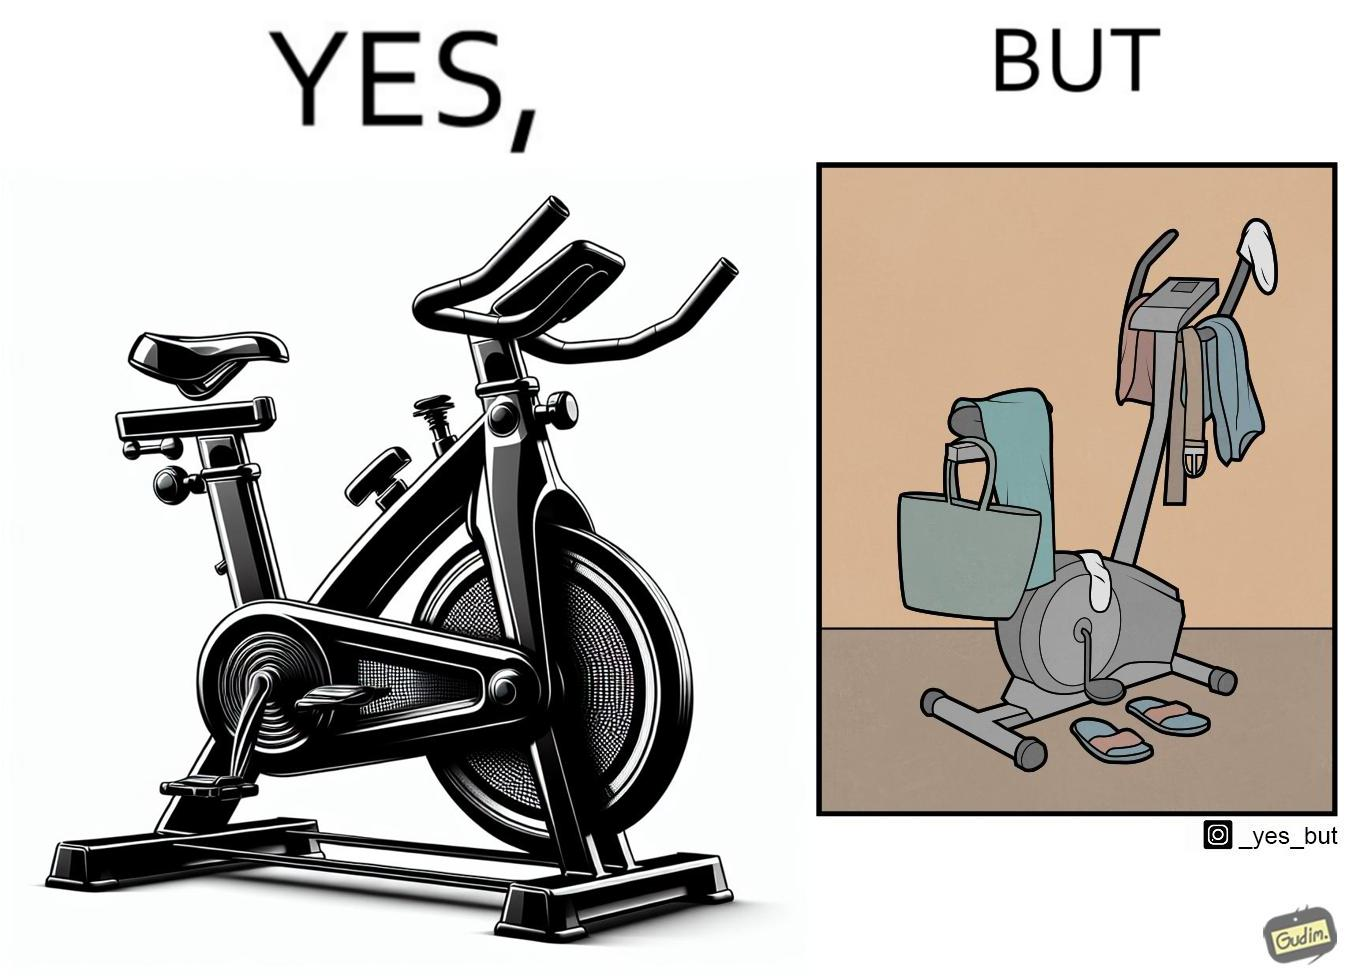What is shown in this image? The images are funny since they show an exercise bike has been bought but is not being used for its purpose, that is, exercising. It is rather being used to hang clothes, bags and other items 